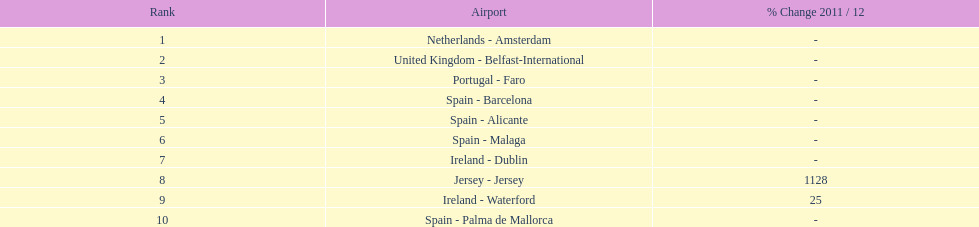Which airports had passengers going through london southend airport? Netherlands - Amsterdam, United Kingdom - Belfast-International, Portugal - Faro, Spain - Barcelona, Spain - Alicante, Spain - Malaga, Ireland - Dublin, Jersey - Jersey, Ireland - Waterford, Spain - Palma de Mallorca. Of those airports, which airport had the least amount of passengers going through london southend airport? Spain - Palma de Mallorca. 